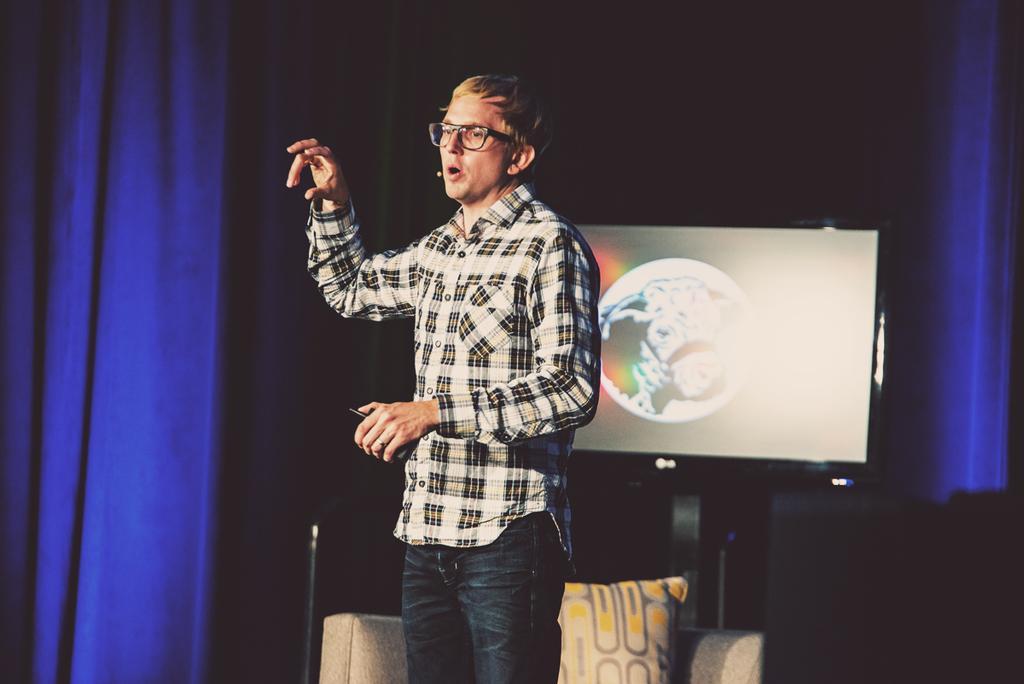Describe this image in one or two sentences. In this picture we can see a man holding an object and explaining something. Behind the man, there is a cushion on the chair and there is a television. Behind the television, there is a dark background. On the left and right side of the image, there are curtains. 